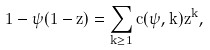Convert formula to latex. <formula><loc_0><loc_0><loc_500><loc_500>1 - \psi ( 1 - z ) = \sum _ { k \geq 1 } c ( \psi , k ) z ^ { k } ,</formula> 